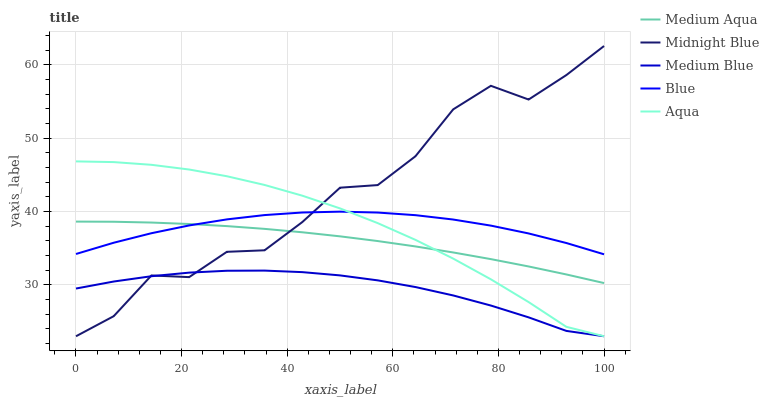Does Medium Blue have the minimum area under the curve?
Answer yes or no. Yes. Does Midnight Blue have the maximum area under the curve?
Answer yes or no. Yes. Does Aqua have the minimum area under the curve?
Answer yes or no. No. Does Aqua have the maximum area under the curve?
Answer yes or no. No. Is Medium Aqua the smoothest?
Answer yes or no. Yes. Is Midnight Blue the roughest?
Answer yes or no. Yes. Is Medium Blue the smoothest?
Answer yes or no. No. Is Medium Blue the roughest?
Answer yes or no. No. Does Medium Blue have the lowest value?
Answer yes or no. Yes. Does Medium Aqua have the lowest value?
Answer yes or no. No. Does Midnight Blue have the highest value?
Answer yes or no. Yes. Does Aqua have the highest value?
Answer yes or no. No. Is Medium Blue less than Blue?
Answer yes or no. Yes. Is Medium Aqua greater than Medium Blue?
Answer yes or no. Yes. Does Aqua intersect Medium Blue?
Answer yes or no. Yes. Is Aqua less than Medium Blue?
Answer yes or no. No. Is Aqua greater than Medium Blue?
Answer yes or no. No. Does Medium Blue intersect Blue?
Answer yes or no. No. 